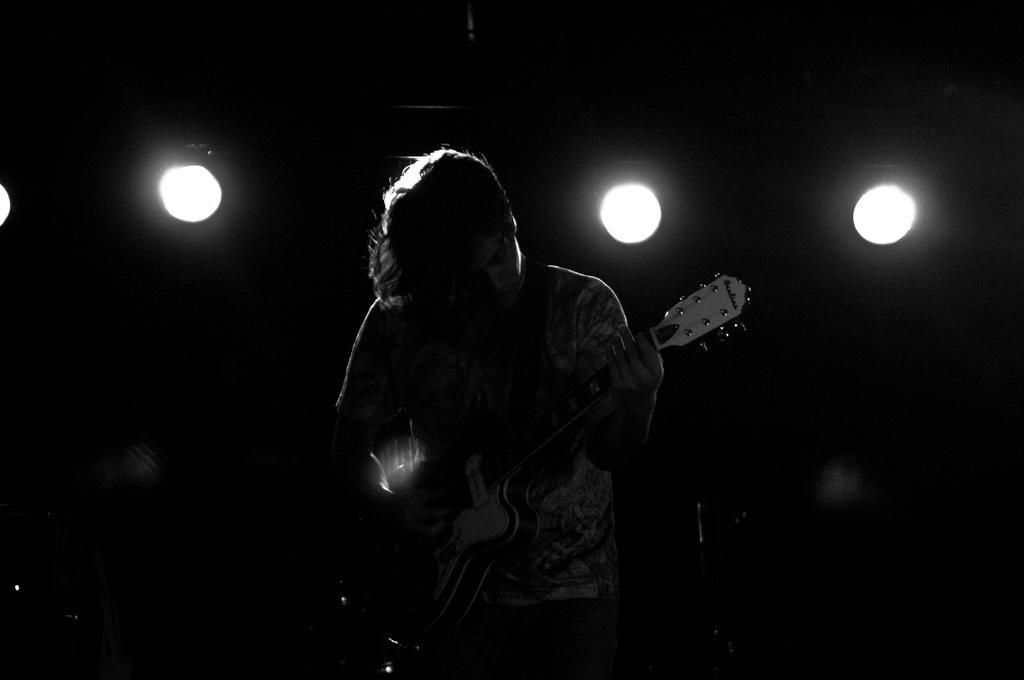Can you describe this image briefly? In the image we can see there is a man who is standing and holding guitar in his hand. 